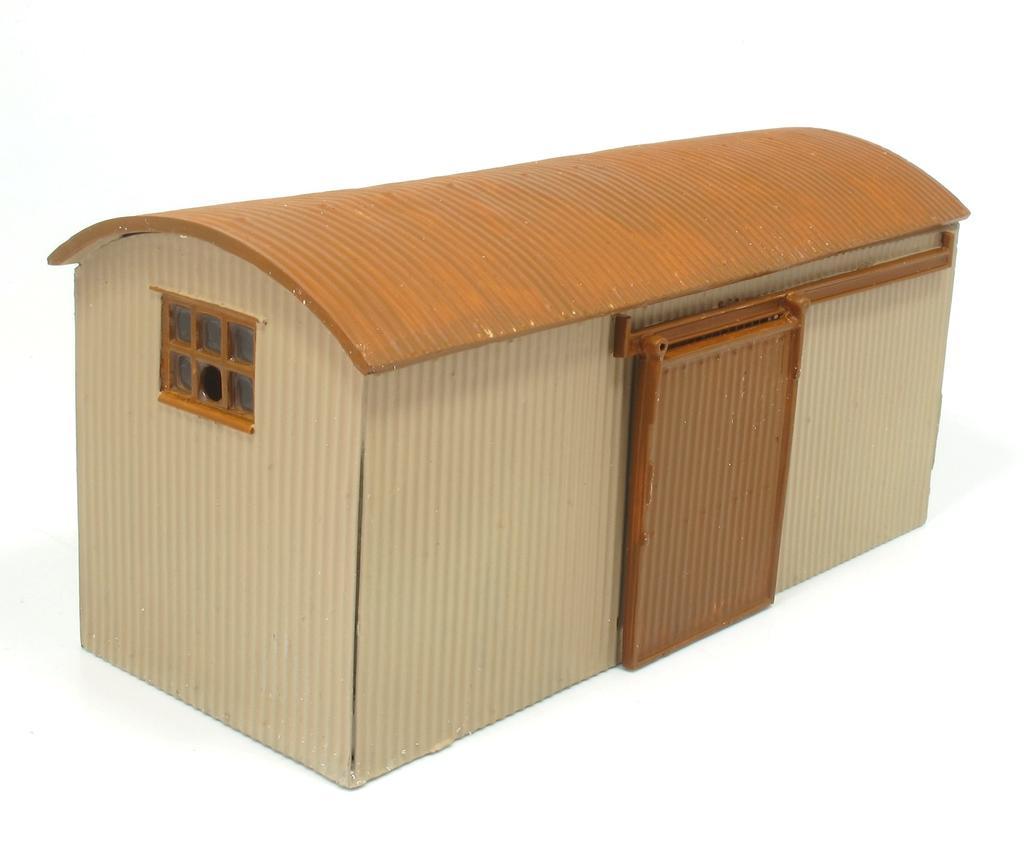Please provide a concise description of this image. In the middle of this image, there is a shelter having a door, a roof and a window. And the background is white in color. 